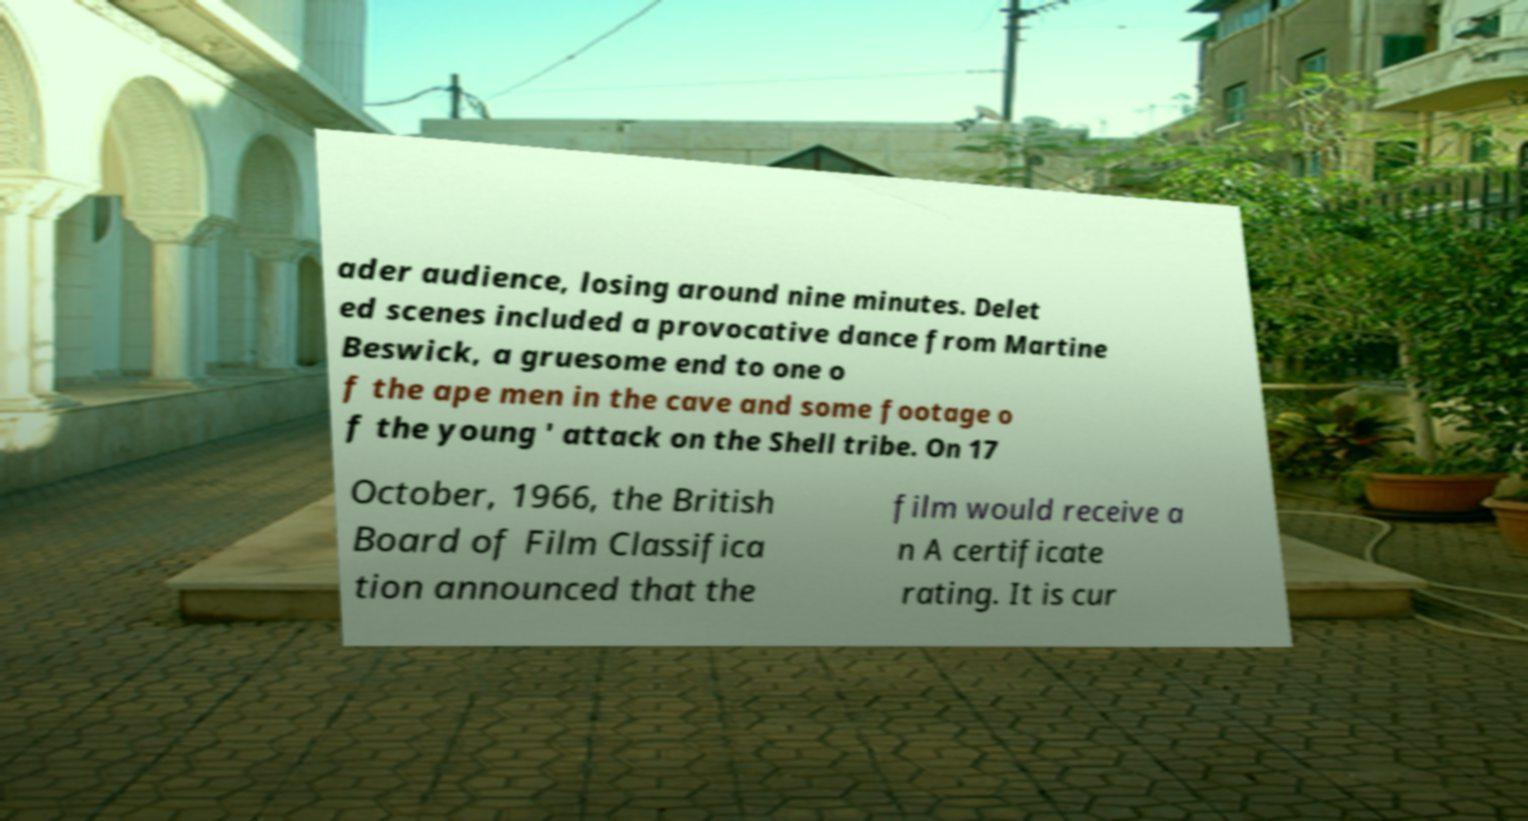Could you assist in decoding the text presented in this image and type it out clearly? ader audience, losing around nine minutes. Delet ed scenes included a provocative dance from Martine Beswick, a gruesome end to one o f the ape men in the cave and some footage o f the young ' attack on the Shell tribe. On 17 October, 1966, the British Board of Film Classifica tion announced that the film would receive a n A certificate rating. It is cur 